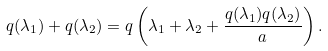<formula> <loc_0><loc_0><loc_500><loc_500>q ( \lambda _ { 1 } ) + q ( \lambda _ { 2 } ) = q \left ( \lambda _ { 1 } + \lambda _ { 2 } + \frac { q ( \lambda _ { 1 } ) q ( \lambda _ { 2 } ) } a \right ) .</formula> 